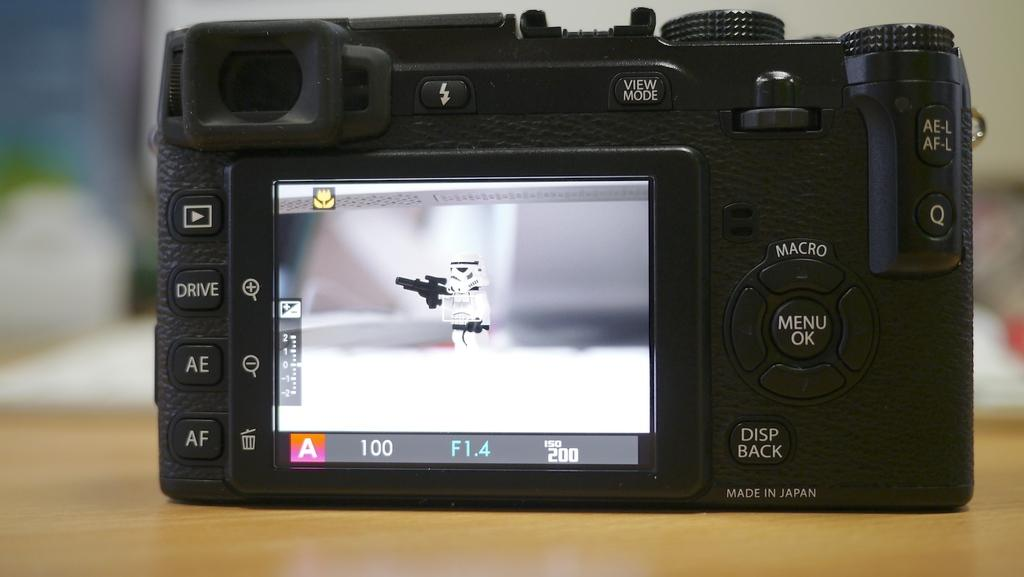What type of camera is visible in the image? There is a black color digital camera in the image. Where is the digital camera placed? The digital camera is placed on a wooden table top. Can you describe the background of the image? The background of the image is blurred. What type of nail is being used to produce the wooden table top? There is no nail visible in the image, and the type of nail used for the wooden table top cannot be determined from the image. 